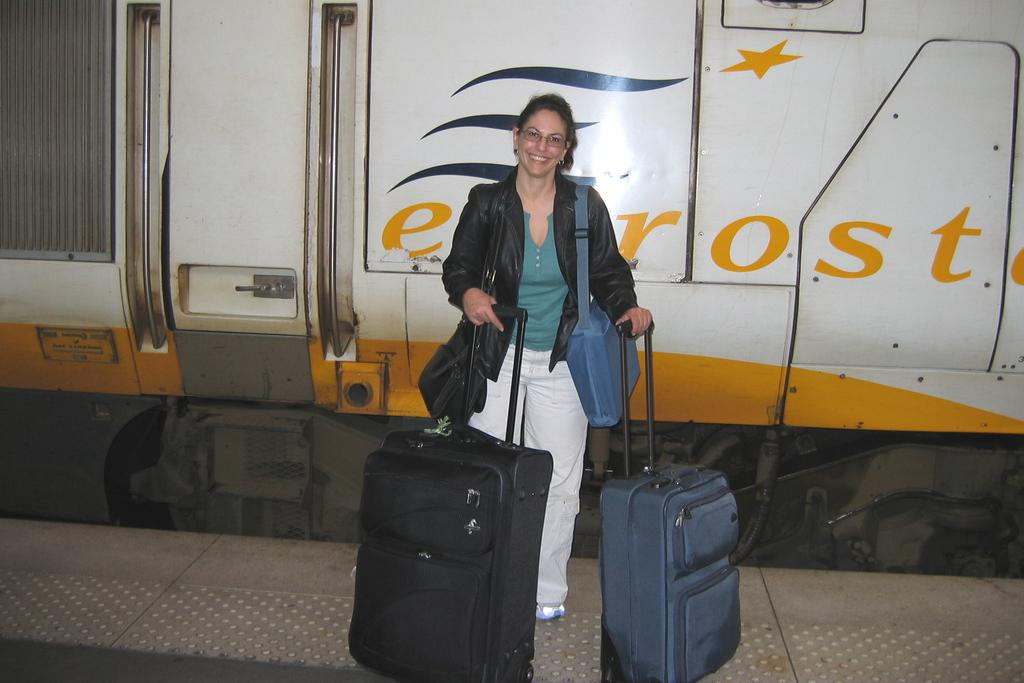Who is the main subject in the image? There is a woman in the image. What is the woman doing in the image? The woman is standing and holding luggage bags and trolleys. What is the woman wearing in the image? The woman is wearing a black color jacket. What type of cannon is visible in the image? There is no cannon present in the image. How many wings does the woman have in the image? The woman does not have any wings in the image. 